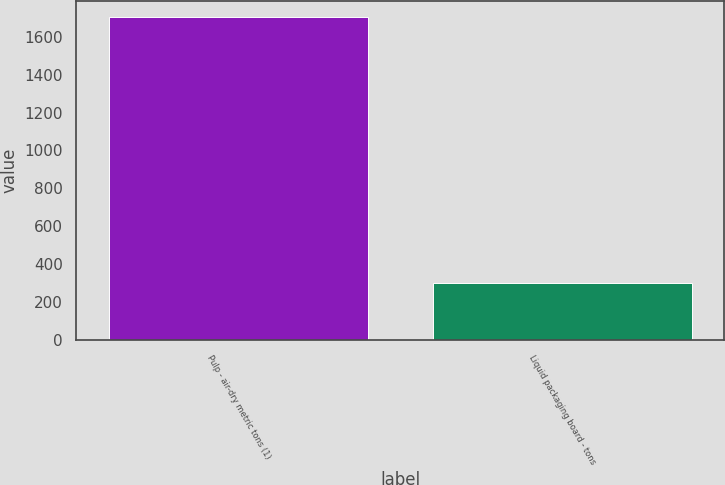<chart> <loc_0><loc_0><loc_500><loc_500><bar_chart><fcel>Pulp - air-dry metric tons (1)<fcel>Liquid packaging board - tons<nl><fcel>1704<fcel>302<nl></chart> 